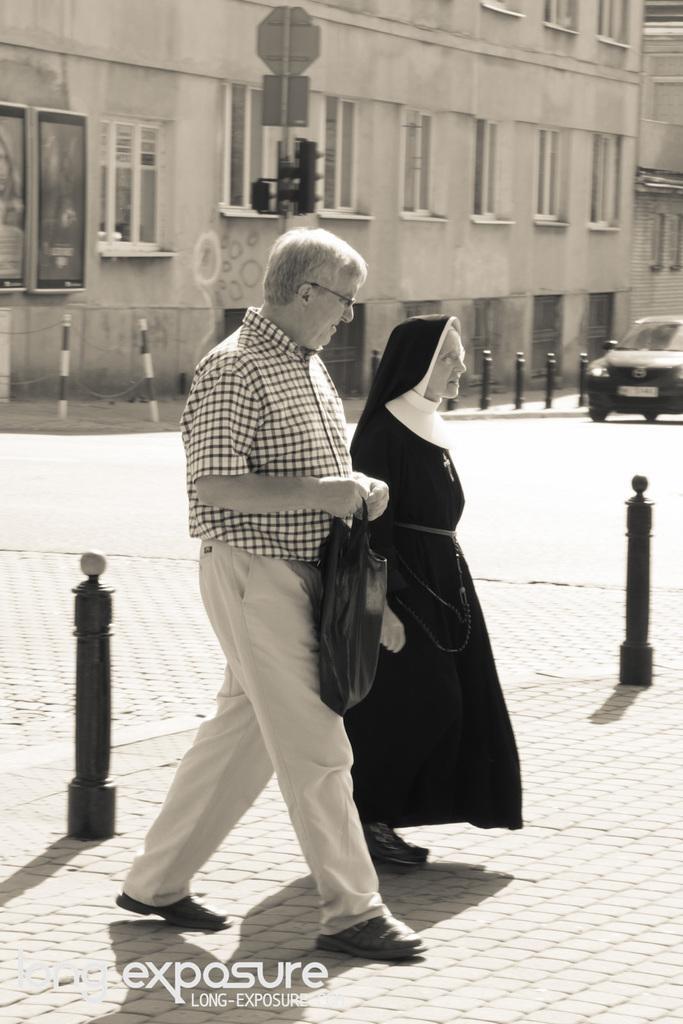Please provide a concise description of this image. This is a black and white image. There is a building at the top. There is a car on the right side. There are two persons in the middle. They are walking. One is a woman, another one is man. The man is holding a cover. 